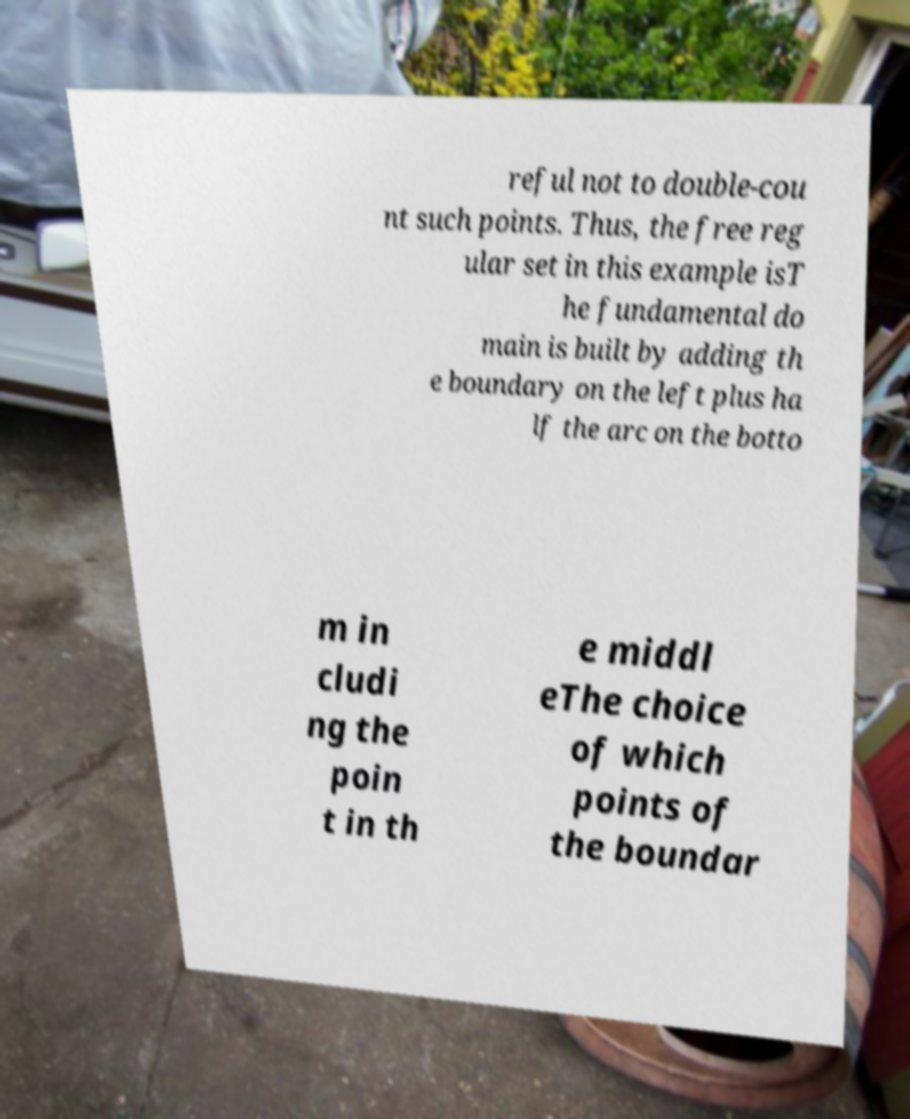Could you assist in decoding the text presented in this image and type it out clearly? reful not to double-cou nt such points. Thus, the free reg ular set in this example isT he fundamental do main is built by adding th e boundary on the left plus ha lf the arc on the botto m in cludi ng the poin t in th e middl eThe choice of which points of the boundar 